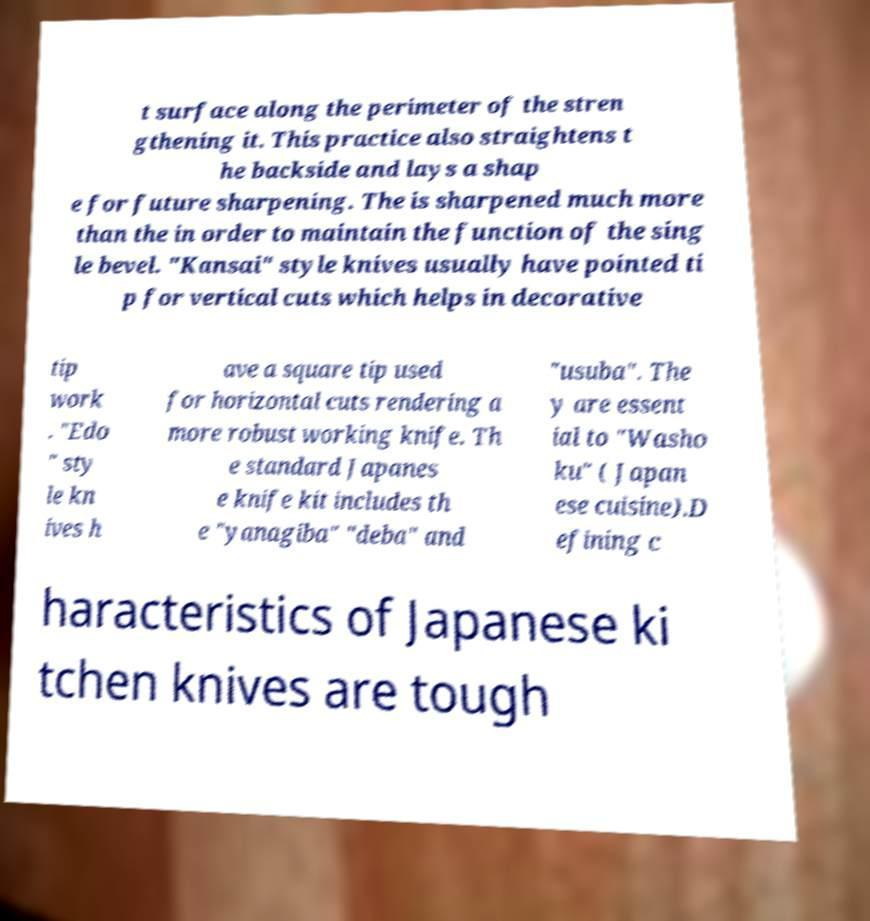For documentation purposes, I need the text within this image transcribed. Could you provide that? t surface along the perimeter of the stren gthening it. This practice also straightens t he backside and lays a shap e for future sharpening. The is sharpened much more than the in order to maintain the function of the sing le bevel. "Kansai" style knives usually have pointed ti p for vertical cuts which helps in decorative tip work . "Edo " sty le kn ives h ave a square tip used for horizontal cuts rendering a more robust working knife. Th e standard Japanes e knife kit includes th e "yanagiba" "deba" and "usuba". The y are essent ial to "Washo ku" ( Japan ese cuisine).D efining c haracteristics of Japanese ki tchen knives are tough 